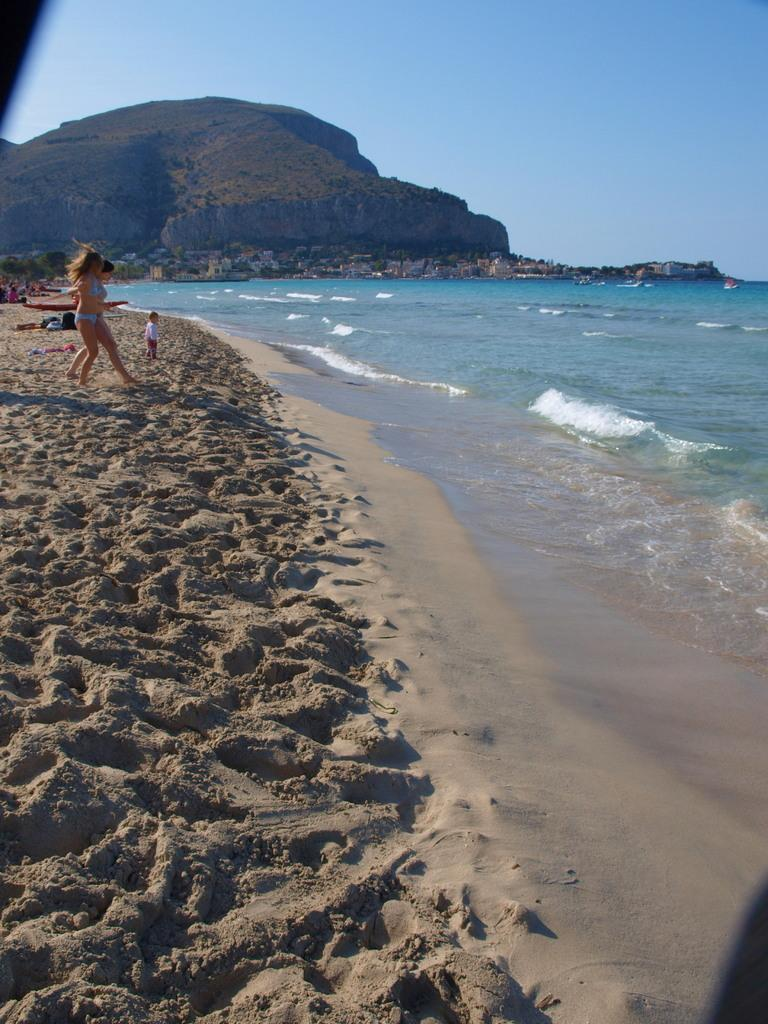What is on the sand in the image? There are persons and objects on the sand. What can be seen on the water on the right side of the image? There are boats on the water on the right side of the image. What is visible in the background of the image? Houses, trees, a cliff, and the sky are visible in the background of the image. Can you tell me how many zippers are visible on the persons in the image? There is no mention of zippers in the image, so it is not possible to determine how many are visible. Is there a cork floating in the water near the boats? There is no mention of a cork in the image, so it is not possible to determine if one is present. 